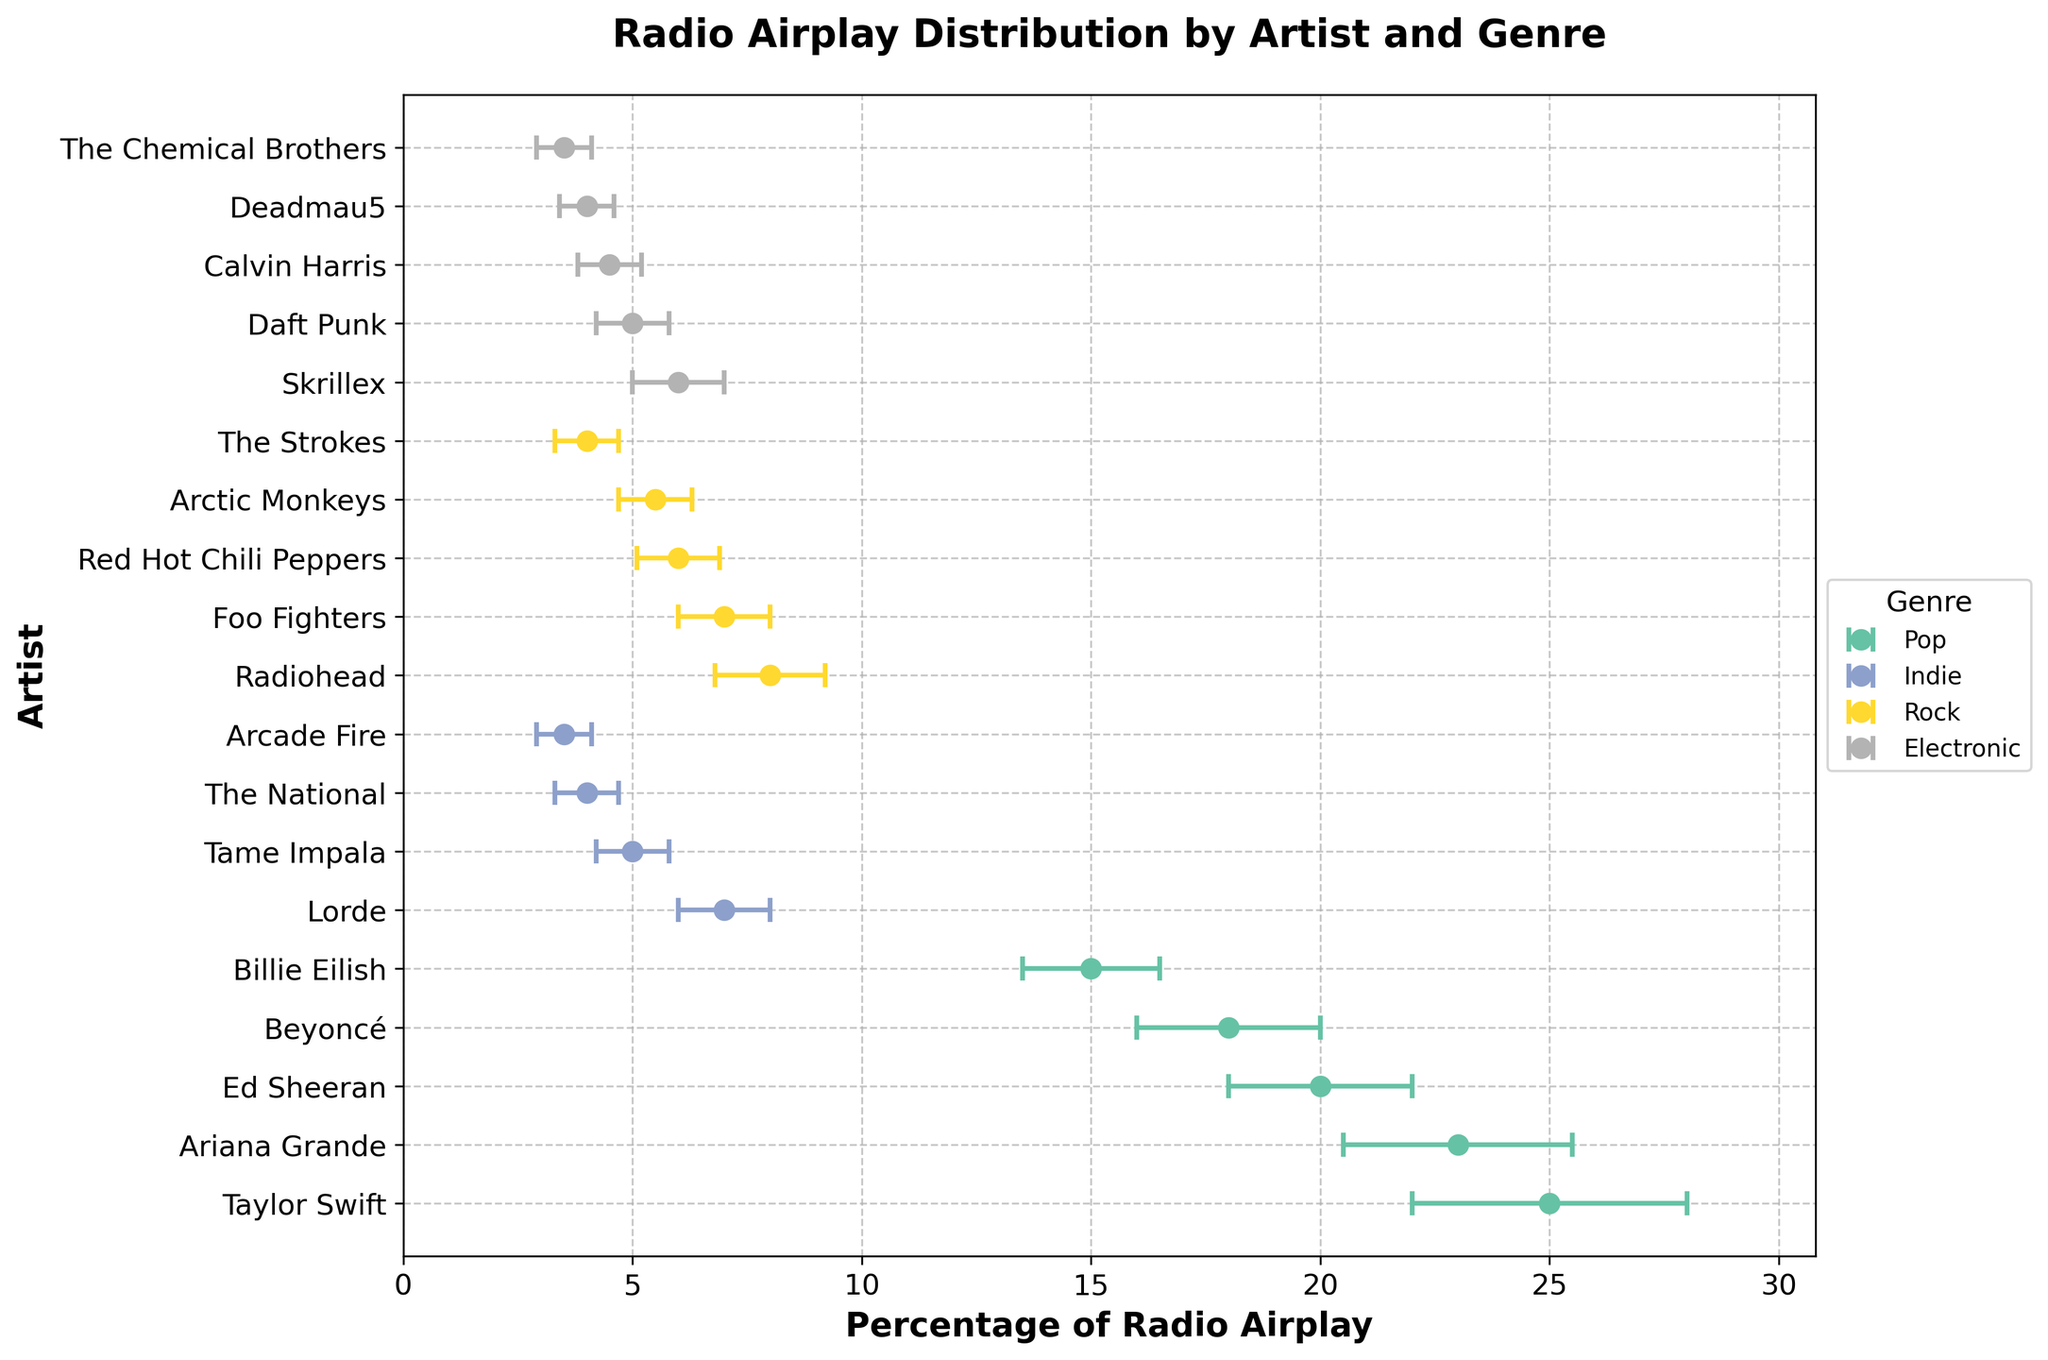how many genres are represented in the figure? The figure shows various genres, each represented by different colored dots. By counting the unique genres listed in the legend or identifying them in the plot, we see four distinct genres: Pop, Indie, Rock, and Electronic.
Answer: Four How many artists in the figure are classified under the Indie genre? To find the number of Indie artists, look for dots corresponding to the Indie genre in the legend and count each one in the plot. The artists classified under Indie are Lorde, Tame Impala, The National, and Arcade Fire.
Answer: Four Which artist has the lowest percentage of radio airplay among all listed artists? By observing the x-axis for the lowest percentage marker and identifying the corresponding point on the plot, we see that Arcade Fire has the lowest percentage of radio airplay at 3.5%.
Answer: Arcade Fire How does the average radio airplay time for Indie artists compare with Pop artists? Calculate the average radio airplay for each genre by summing the percentages and dividing by the count of artists. For Indie: (7 + 5 + 4 + 3.5)/4 = 4.875%. For Pop: (25 + 23 + 20 + 18 + 15)/5 = 20.2%. Notice that Pop average (20.2%) is significantly higher than Indie average (4.875%).
Answer: Pop has higher average What's the range of radio airplay percentages for Rock artists? Determine the range by finding the highest and lowest points among Rock artists and calculating the difference. The Rock artists' percentages range from Radiohead's 8% to The Strokes' 4%, giving a range of 8 - 4 = 4%.
Answer: 4% Which artist among the listed Pop stars has the most significant margin of error in their radio airplay percentage? By observing the length of the error bars among Pop stars, the artist with the largest error value can be identified. Taylor Swift, with an error of 3%, has the most significant error margin.
Answer: Taylor Swift By how much does the radio airplay of Foo Fighters exceed that of The Strokes? Calculate the difference in their percentages by subtracting The Strokes' value from Foo Fighters'. Foo Fighters have 7%, and The Strokes have 4%, resulting in a difference of 7 - 4 = 3%.
Answer: 3% Which genre has the smallest margin of error on average? Calculate the average error for each genre by summing the error values and dividing by the count of artists. The averages are: Pop = (3 + 2.5 + 2 + 2 + 1.5)/5 = 2.2, Indie = (1 + 0.8 + 0.7 + 0.6)/4 = 0.775, Rock = (1.2 + 1 + 0.9 + 0.8 + 0.7)/5 = 0.92, Electronic = (1 + 0.8 + 0.7 + 0.6 + 0.6)/5 = 0.74. Thus, Electronic has the smallest average error.
Answer: Electronic 